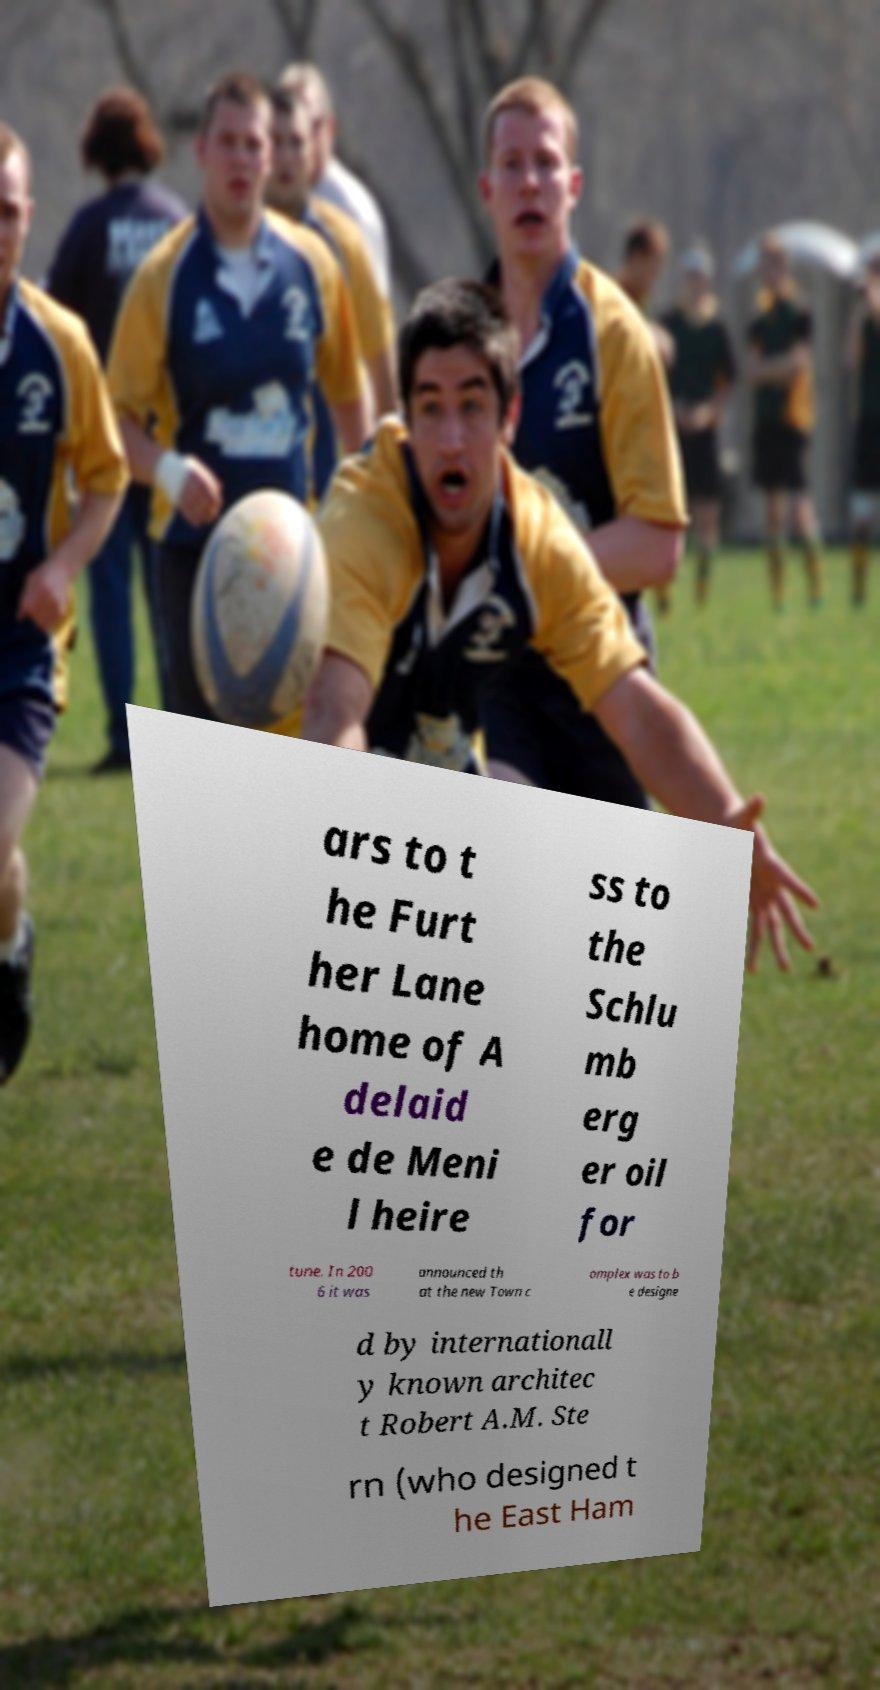Can you accurately transcribe the text from the provided image for me? ars to t he Furt her Lane home of A delaid e de Meni l heire ss to the Schlu mb erg er oil for tune. In 200 6 it was announced th at the new Town c omplex was to b e designe d by internationall y known architec t Robert A.M. Ste rn (who designed t he East Ham 